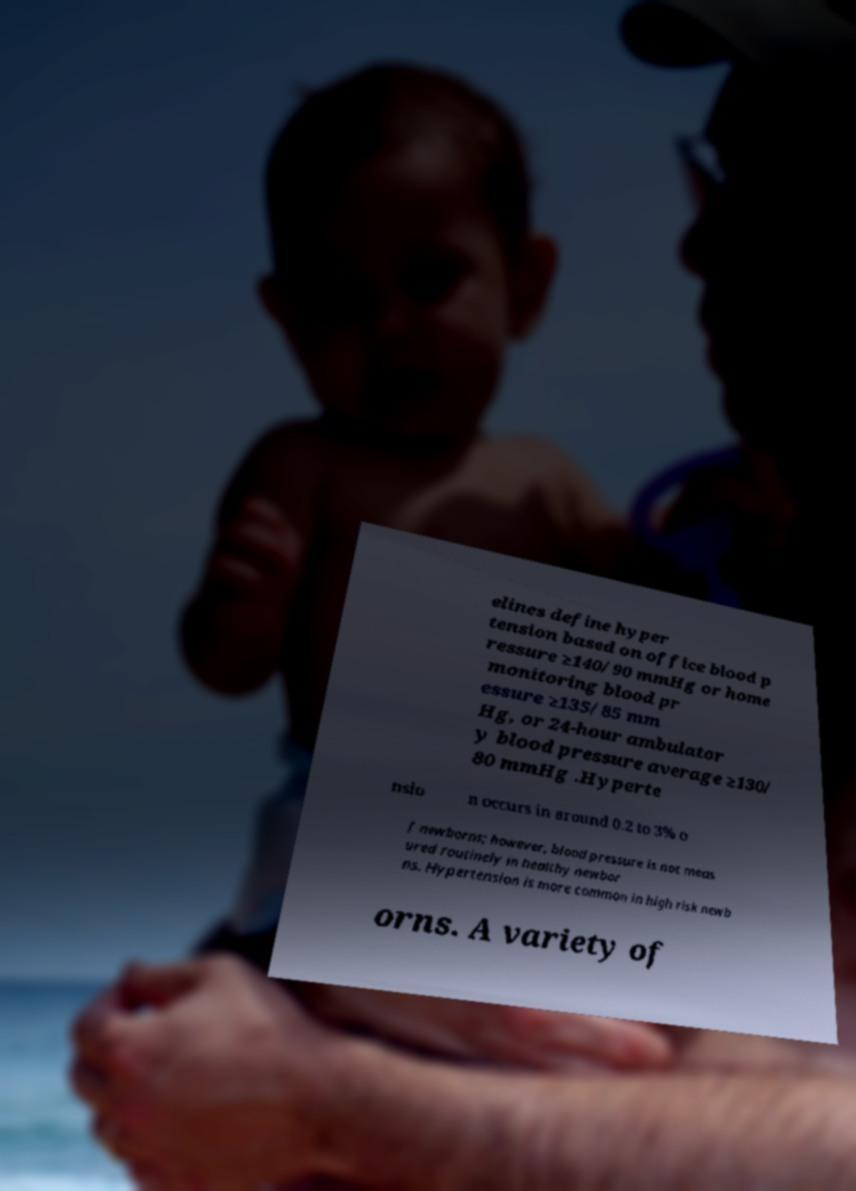For documentation purposes, I need the text within this image transcribed. Could you provide that? elines define hyper tension based on office blood p ressure ≥140/90 mmHg or home monitoring blood pr essure ≥135/85 mm Hg, or 24-hour ambulator y blood pressure average ≥130/ 80 mmHg .Hyperte nsio n occurs in around 0.2 to 3% o f newborns; however, blood pressure is not meas ured routinely in healthy newbor ns. Hypertension is more common in high risk newb orns. A variety of 